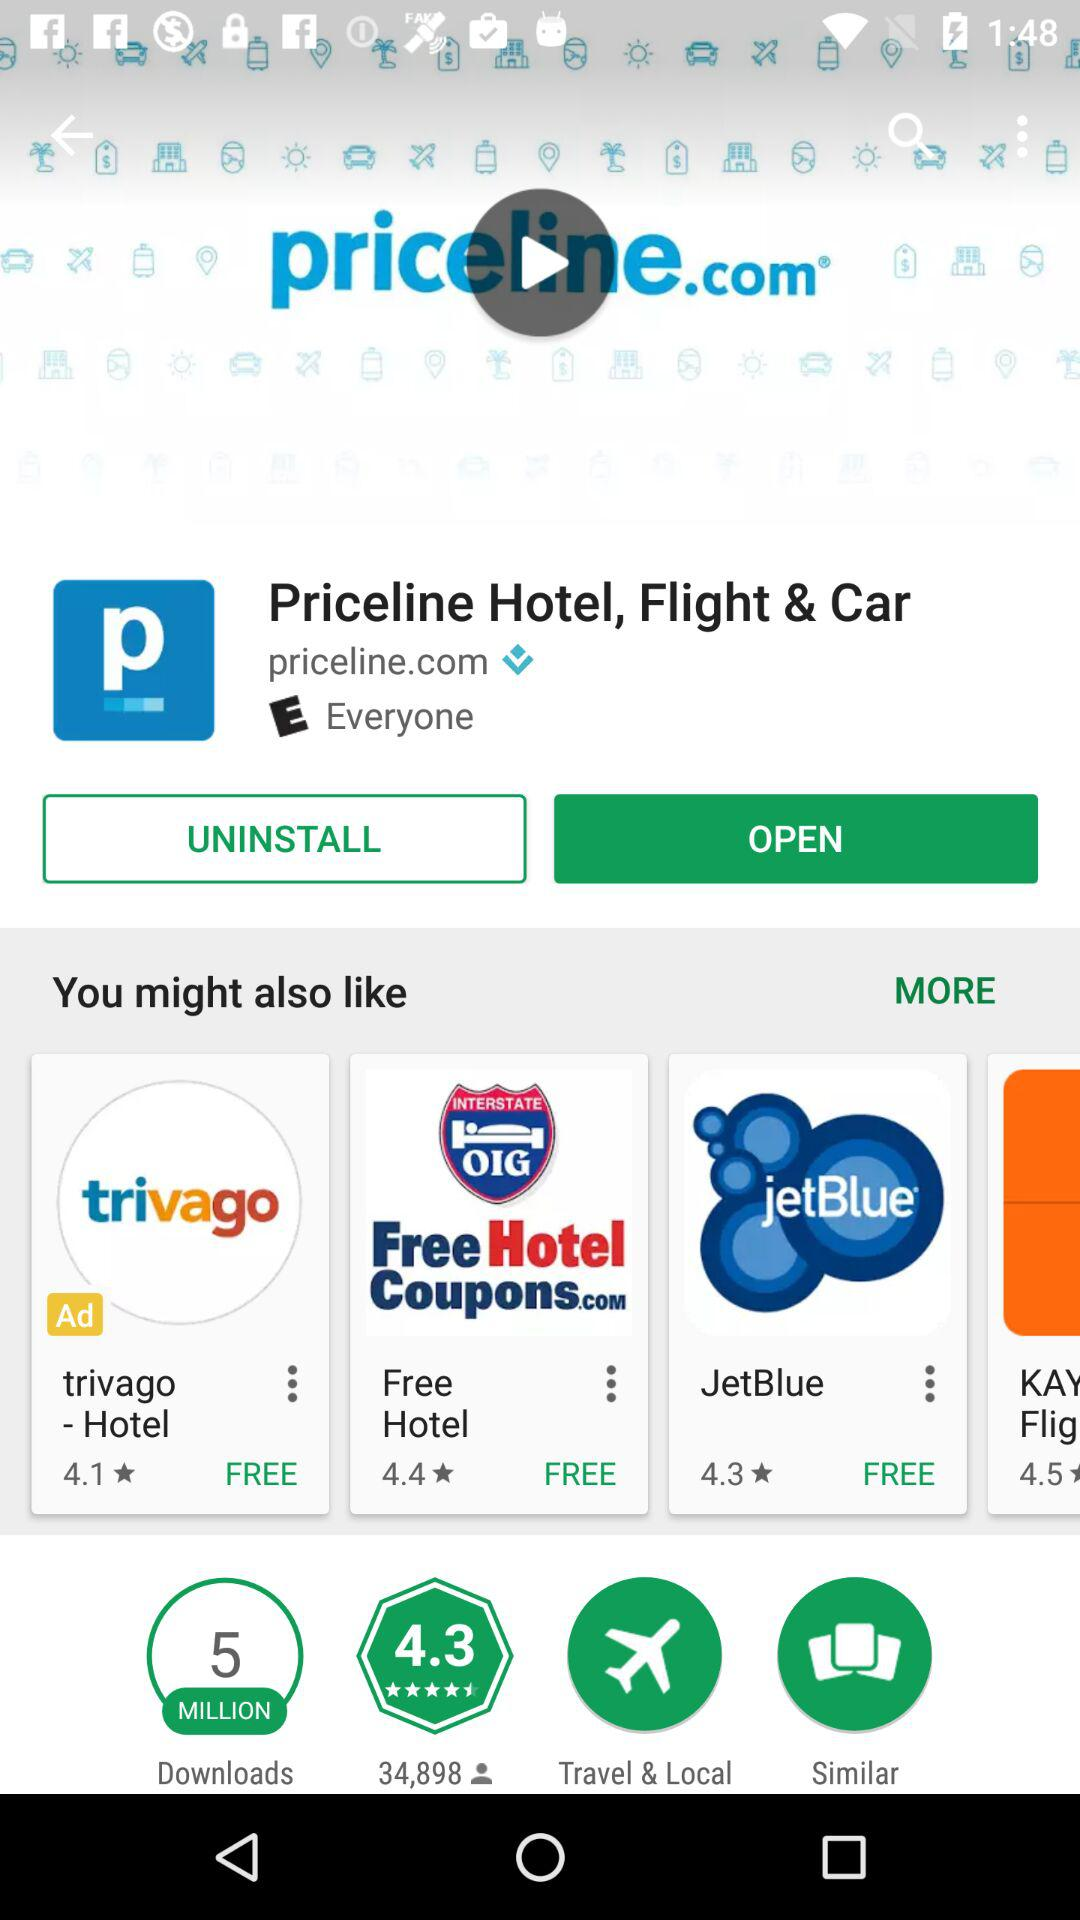What is the cost of an application named JetBlue? The application is free of cost. 